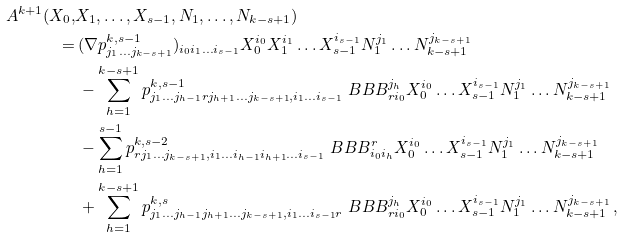Convert formula to latex. <formula><loc_0><loc_0><loc_500><loc_500>A ^ { k + 1 } ( X _ { 0 } , & X _ { 1 } , \dots , X _ { s - 1 } , N _ { 1 } , \dots , N _ { k - s + 1 } ) \\ = & \, ( \nabla p ^ { k , s - 1 } _ { j _ { 1 } \dots j _ { k - s + 1 } } ) _ { i _ { 0 } i _ { 1 } \dots i _ { s - 1 } } X _ { 0 } ^ { i _ { 0 } } X _ { 1 } ^ { i _ { 1 } } \dots X _ { s - 1 } ^ { i _ { s - 1 } } N _ { 1 } ^ { j _ { 1 } } \dots N _ { k - s + 1 } ^ { j _ { k - s + 1 } } \\ & \, - \sum _ { h = 1 } ^ { k - s + 1 } p ^ { k , s - 1 } _ { j _ { 1 } \dots j _ { h - 1 } r j _ { h + 1 } \dots j _ { k - s + 1 } , i _ { 1 } \dots i _ { s - 1 } } \ B B B _ { r i _ { 0 } } ^ { j _ { h } } X _ { 0 } ^ { i _ { 0 } } \dots X _ { s - 1 } ^ { i _ { s - 1 } } N _ { 1 } ^ { j _ { 1 } } \dots N _ { k - s + 1 } ^ { j _ { k - s + 1 } } \\ & \, - \sum _ { h = 1 } ^ { s - 1 } p ^ { k , s - 2 } _ { r j _ { 1 } \dots j _ { k - s + 1 } , i _ { 1 } \dots i _ { h - 1 } i _ { h + 1 } \dots i _ { s - 1 } } \ B B B ^ { r } _ { i _ { 0 } i _ { h } } X _ { 0 } ^ { i _ { 0 } } \dots X _ { s - 1 } ^ { i _ { s - 1 } } N _ { 1 } ^ { j _ { 1 } } \dots N _ { k - s + 1 } ^ { j _ { k - s + 1 } } \\ & \, + \sum _ { h = 1 } ^ { k - s + 1 } p ^ { k , s } _ { j _ { 1 } \dots j _ { h - 1 } j _ { h + 1 } \dots j _ { k - s + 1 } , i _ { 1 } \dots i _ { s - 1 } r } \ B B B _ { r i _ { 0 } } ^ { j _ { h } } X _ { 0 } ^ { i _ { 0 } } \dots X _ { s - 1 } ^ { i _ { s - 1 } } N _ { 1 } ^ { j _ { 1 } } \dots N _ { k - s + 1 } ^ { j _ { k - s + 1 } } \, ,</formula> 